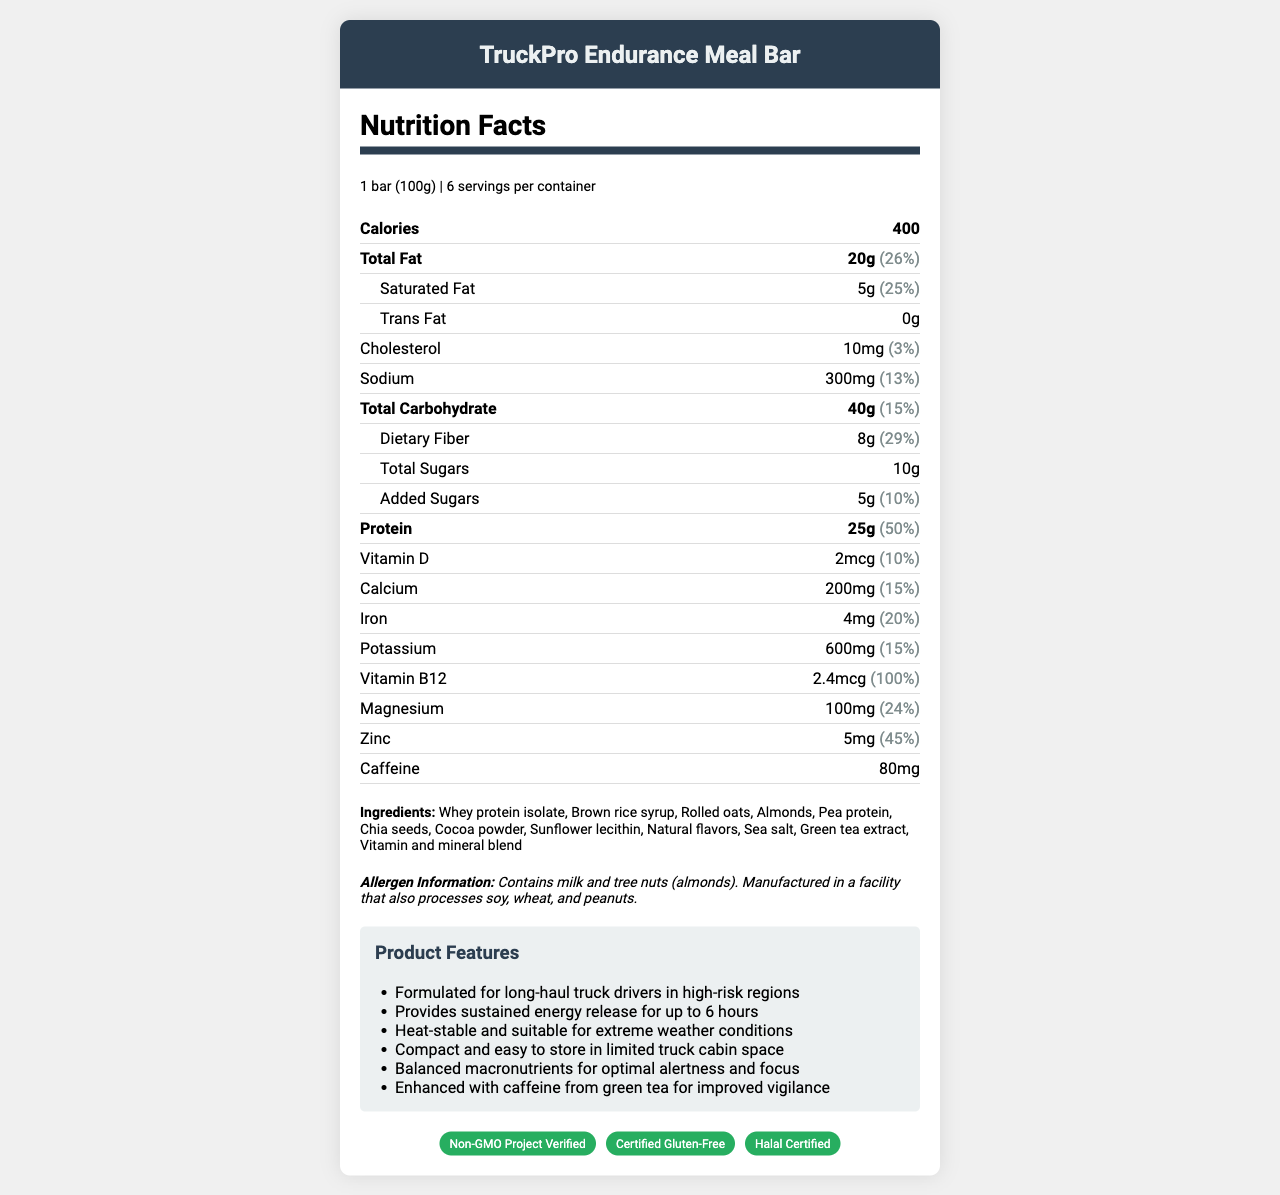what is the serving size for the TruckPro Endurance Meal Bar? The serving size is listed as "1 bar (100g)" in the document.
Answer: 1 bar (100g) how many calories are in one serving of the TruckPro Endurance Meal Bar? The calories per serving are specified directly as 400 in the document.
Answer: 400 calories which ingredients in the TruckPro Endurance Meal Bar might trigger allergies? The allergen information states that the product contains milk and tree nuts (almonds).
Answer: Milk and tree nuts (almonds) how much protein does one bar of the TruckPro Endurance Meal Bar contain? The document states that it contains 25g of protein per bar.
Answer: 25g how many servings are there in one container of TruckPro Endurance Meal Bar? The servings per container are listed as 6 in the document.
Answer: 6 what is the amount of dietary fiber in one serving of the TruckPro Endurance Meal Bar? The amount of dietary fiber is listed as 8g per serving.
Answer: 8g what is the daily value percentage of Vitamin B12 in one serving of the TruckPro Endurance Meal Bar? The daily value percentage for Vitamin B12 is noted as 100% in the document.
Answer: 100% what is the recommended storage condition for the TruckPro Endurance Meal Bar? A. Store in a cool, dry place B. Refrigerate C. Freeze D. Keep at room temperature The document states "Store in a cool, dry place."
Answer: A which certification is not listed for the TruckPro Endurance Meal Bar? A. Non-GMO Project Verified B. Certified Gluten-Free C. Organic Certified D. Halal Certified The Product Features and Certifications sections list "Non-GMO Project Verified," "Certified Gluten-Free," and "Halal Certified," but not "Organic Certified."
Answer: C is the TruckPro Endurance Meal Bar suitable for consumption in extreme temperatures? The storage instructions indicate it is suitable for extreme temperatures ranging from -20°C to 50°C.
Answer: Yes does the TruckPro Endurance Meal Bar contain any trans fat? The document states that the trans fat content is 0g.
Answer: No summarize the main features of the TruckPro Endurance Meal Bar. This summary captures the essential details including nutritional content, purpose, features, and certifications.
Answer: The TruckPro Endurance Meal Bar is a compact, nutrient-dense meal replacement designed for long-haul truck drivers. Each bar (100g) contains 400 calories, 20g of total fat, 40g of carbohydrates, and 25g of protein. It offers sustained energy release for up to 6 hours and is suitable for extreme weather conditions. The bar is enhanced with 80mg of caffeine from green tea for improved vigilance. It is Non-GMO, Gluten-Free, and Halal Certified, and contains ingredients like whey protein isolate, rolled oats, and chia seeds. Allergen information includes milk and tree nuts (almonds). what is the main source of caffeine in the TruckPro Endurance Meal Bar? The ingredients list specifies caffeine as coming from green tea extract.
Answer: Green tea extract what should be noted about the cholesterol content in the TruckPro Endurance Meal Bar? The document lists cholesterol content as 10mg which is 3% of the daily value.
Answer: 10mg (3% daily value) can someone on a vegan diet consume the TruckPro Endurance Meal Bar? The ingredient list includes whey protein isolate, which is derived from milk, making it unsuitable for a vegan diet.
Answer: No how are proteins in the TruckPro Endurance Meal Bar sourced? A. Animal-based B. Plant-based C. Both The meal bar includes whey protein isolate (animal-based) and pea protein (plant-based).
Answer: C 